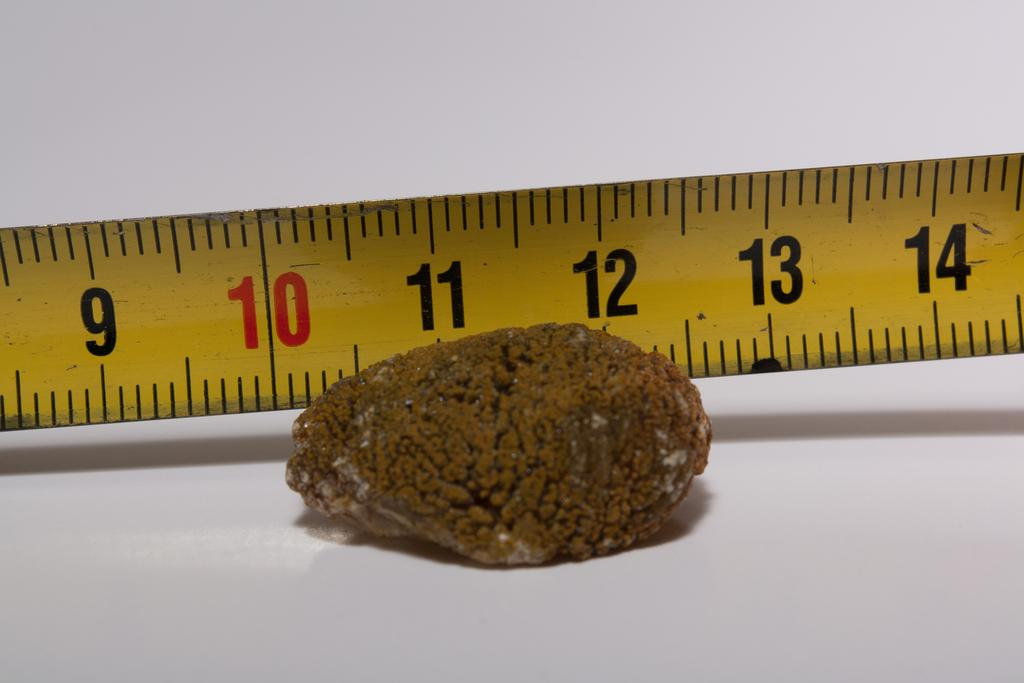<image>
Write a terse but informative summary of the picture. A clump of something brown is sitting lined up with the 10 inch mark on a ruler. 